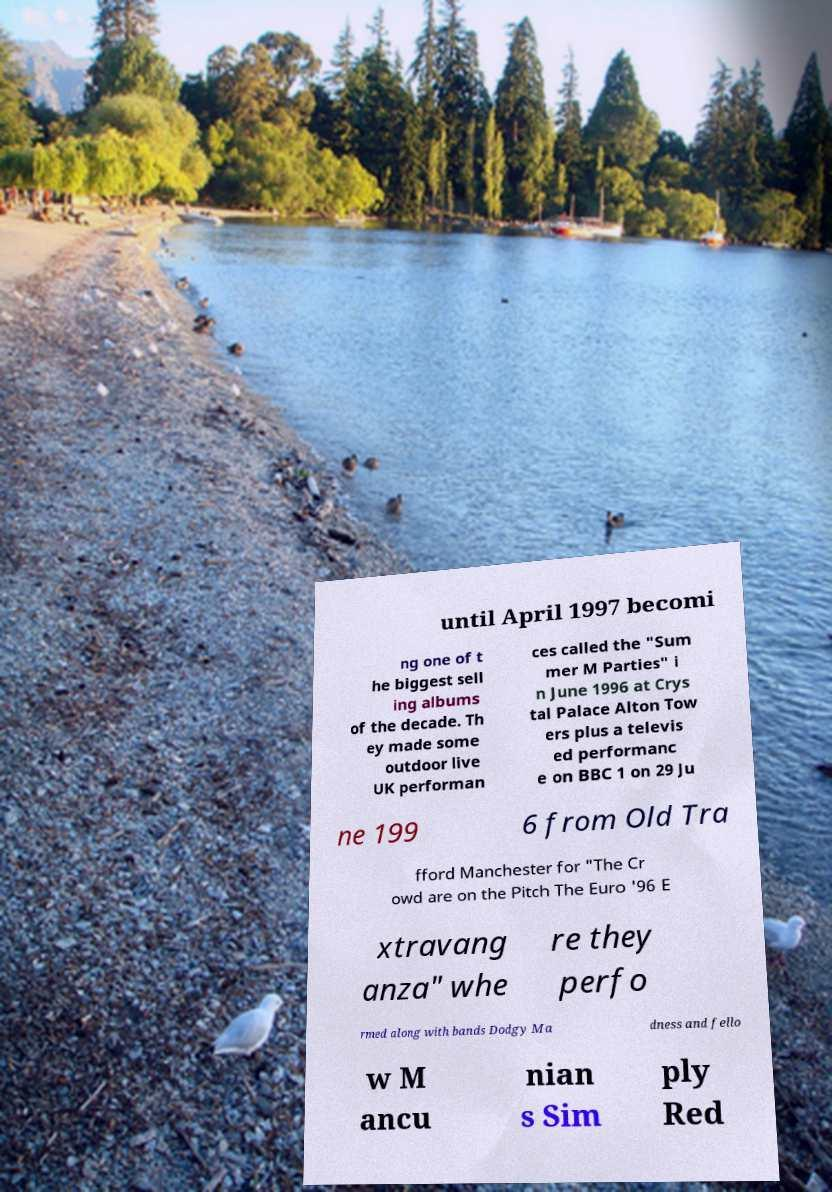There's text embedded in this image that I need extracted. Can you transcribe it verbatim? until April 1997 becomi ng one of t he biggest sell ing albums of the decade. Th ey made some outdoor live UK performan ces called the "Sum mer M Parties" i n June 1996 at Crys tal Palace Alton Tow ers plus a televis ed performanc e on BBC 1 on 29 Ju ne 199 6 from Old Tra fford Manchester for "The Cr owd are on the Pitch The Euro '96 E xtravang anza" whe re they perfo rmed along with bands Dodgy Ma dness and fello w M ancu nian s Sim ply Red 